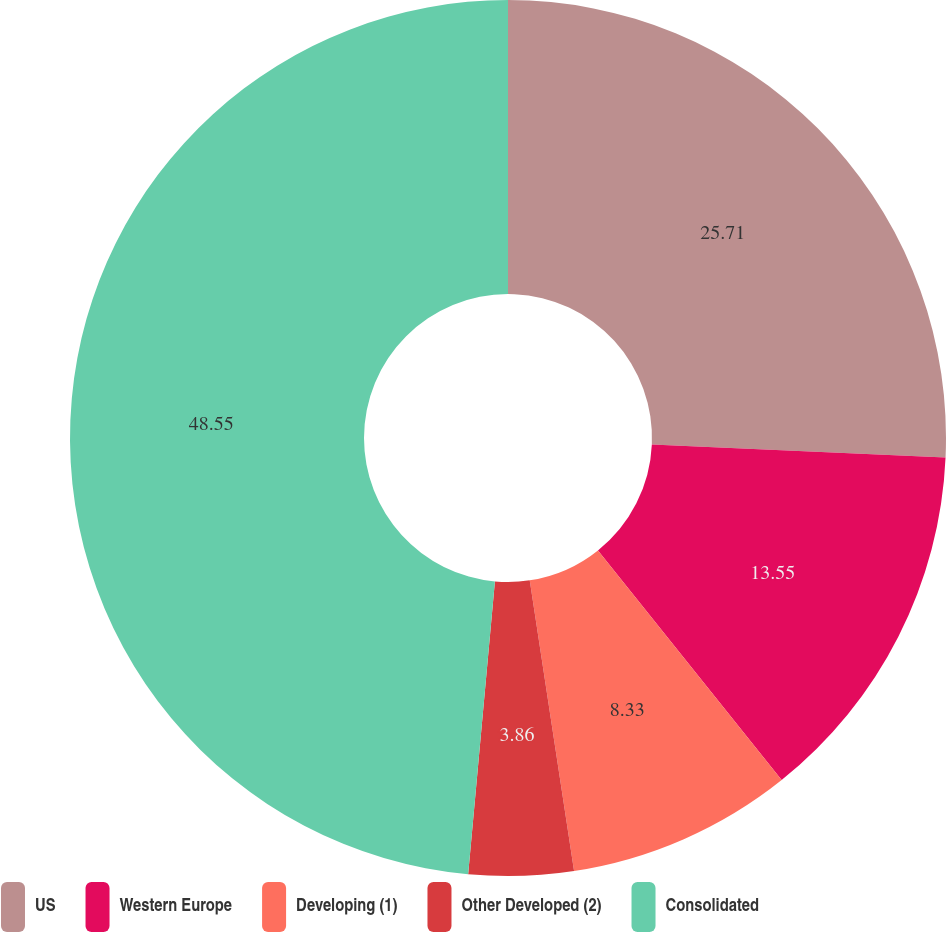Convert chart. <chart><loc_0><loc_0><loc_500><loc_500><pie_chart><fcel>US<fcel>Western Europe<fcel>Developing (1)<fcel>Other Developed (2)<fcel>Consolidated<nl><fcel>25.71%<fcel>13.55%<fcel>8.33%<fcel>3.86%<fcel>48.55%<nl></chart> 